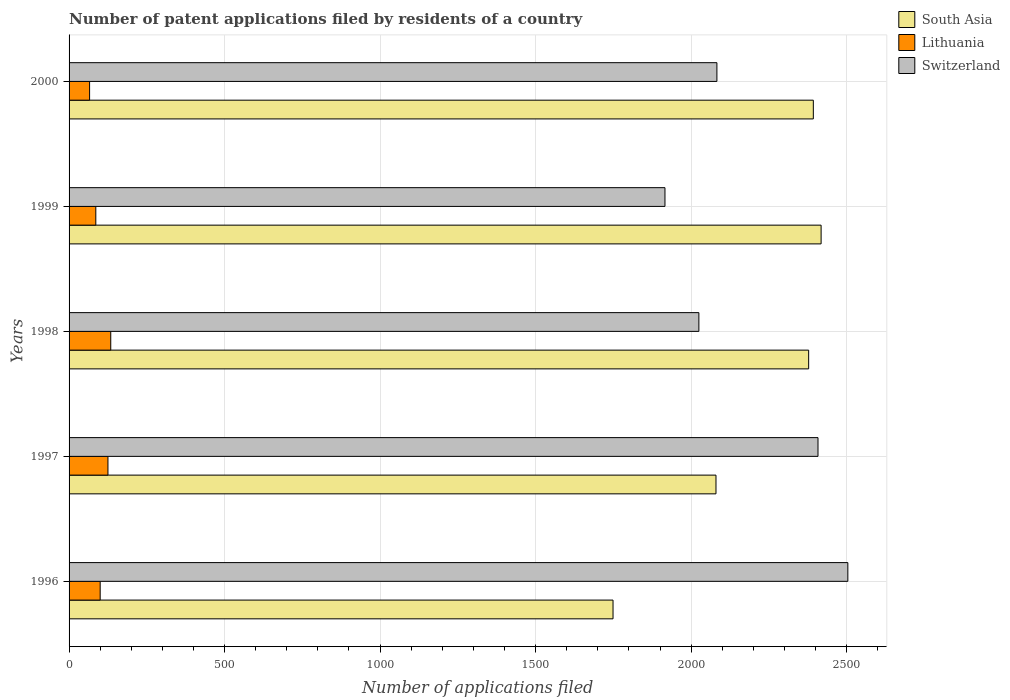How many different coloured bars are there?
Give a very brief answer. 3. How many groups of bars are there?
Your response must be concise. 5. Are the number of bars on each tick of the Y-axis equal?
Offer a terse response. Yes. How many bars are there on the 2nd tick from the top?
Offer a very short reply. 3. In how many cases, is the number of bars for a given year not equal to the number of legend labels?
Give a very brief answer. 0. What is the number of applications filed in Switzerland in 2000?
Offer a terse response. 2083. Across all years, what is the maximum number of applications filed in Lithuania?
Your response must be concise. 134. In which year was the number of applications filed in South Asia minimum?
Your response must be concise. 1996. What is the total number of applications filed in Switzerland in the graph?
Your response must be concise. 1.09e+04. What is the difference between the number of applications filed in South Asia in 1996 and that in 1999?
Give a very brief answer. -669. What is the difference between the number of applications filed in Switzerland in 2000 and the number of applications filed in Lithuania in 1997?
Keep it short and to the point. 1958. What is the average number of applications filed in South Asia per year?
Make the answer very short. 2203.6. In the year 1997, what is the difference between the number of applications filed in Lithuania and number of applications filed in South Asia?
Offer a very short reply. -1955. What is the ratio of the number of applications filed in South Asia in 1996 to that in 1997?
Give a very brief answer. 0.84. Is the difference between the number of applications filed in Lithuania in 1997 and 1999 greater than the difference between the number of applications filed in South Asia in 1997 and 1999?
Give a very brief answer. Yes. What is the difference between the highest and the second highest number of applications filed in South Asia?
Your response must be concise. 25. What is the difference between the highest and the lowest number of applications filed in Switzerland?
Provide a succinct answer. 588. In how many years, is the number of applications filed in Switzerland greater than the average number of applications filed in Switzerland taken over all years?
Ensure brevity in your answer.  2. Is the sum of the number of applications filed in Switzerland in 1998 and 1999 greater than the maximum number of applications filed in Lithuania across all years?
Ensure brevity in your answer.  Yes. What does the 2nd bar from the bottom in 2000 represents?
Offer a very short reply. Lithuania. Is it the case that in every year, the sum of the number of applications filed in Lithuania and number of applications filed in Switzerland is greater than the number of applications filed in South Asia?
Provide a short and direct response. No. How many years are there in the graph?
Offer a terse response. 5. Are the values on the major ticks of X-axis written in scientific E-notation?
Your response must be concise. No. What is the title of the graph?
Make the answer very short. Number of patent applications filed by residents of a country. What is the label or title of the X-axis?
Provide a succinct answer. Number of applications filed. What is the label or title of the Y-axis?
Make the answer very short. Years. What is the Number of applications filed in South Asia in 1996?
Provide a short and direct response. 1749. What is the Number of applications filed in Lithuania in 1996?
Your answer should be very brief. 100. What is the Number of applications filed in Switzerland in 1996?
Offer a very short reply. 2504. What is the Number of applications filed of South Asia in 1997?
Provide a succinct answer. 2080. What is the Number of applications filed in Lithuania in 1997?
Give a very brief answer. 125. What is the Number of applications filed in Switzerland in 1997?
Your answer should be compact. 2408. What is the Number of applications filed of South Asia in 1998?
Offer a terse response. 2378. What is the Number of applications filed in Lithuania in 1998?
Your answer should be very brief. 134. What is the Number of applications filed of Switzerland in 1998?
Make the answer very short. 2025. What is the Number of applications filed in South Asia in 1999?
Provide a succinct answer. 2418. What is the Number of applications filed in Lithuania in 1999?
Keep it short and to the point. 86. What is the Number of applications filed of Switzerland in 1999?
Ensure brevity in your answer.  1916. What is the Number of applications filed of South Asia in 2000?
Your answer should be very brief. 2393. What is the Number of applications filed of Lithuania in 2000?
Keep it short and to the point. 66. What is the Number of applications filed of Switzerland in 2000?
Make the answer very short. 2083. Across all years, what is the maximum Number of applications filed in South Asia?
Your response must be concise. 2418. Across all years, what is the maximum Number of applications filed in Lithuania?
Your response must be concise. 134. Across all years, what is the maximum Number of applications filed of Switzerland?
Give a very brief answer. 2504. Across all years, what is the minimum Number of applications filed of South Asia?
Keep it short and to the point. 1749. Across all years, what is the minimum Number of applications filed of Switzerland?
Offer a very short reply. 1916. What is the total Number of applications filed of South Asia in the graph?
Your answer should be very brief. 1.10e+04. What is the total Number of applications filed of Lithuania in the graph?
Your answer should be compact. 511. What is the total Number of applications filed in Switzerland in the graph?
Keep it short and to the point. 1.09e+04. What is the difference between the Number of applications filed of South Asia in 1996 and that in 1997?
Give a very brief answer. -331. What is the difference between the Number of applications filed in Lithuania in 1996 and that in 1997?
Give a very brief answer. -25. What is the difference between the Number of applications filed of Switzerland in 1996 and that in 1997?
Your answer should be compact. 96. What is the difference between the Number of applications filed of South Asia in 1996 and that in 1998?
Provide a short and direct response. -629. What is the difference between the Number of applications filed in Lithuania in 1996 and that in 1998?
Provide a succinct answer. -34. What is the difference between the Number of applications filed of Switzerland in 1996 and that in 1998?
Your response must be concise. 479. What is the difference between the Number of applications filed of South Asia in 1996 and that in 1999?
Your answer should be compact. -669. What is the difference between the Number of applications filed in Switzerland in 1996 and that in 1999?
Give a very brief answer. 588. What is the difference between the Number of applications filed in South Asia in 1996 and that in 2000?
Offer a terse response. -644. What is the difference between the Number of applications filed of Switzerland in 1996 and that in 2000?
Your response must be concise. 421. What is the difference between the Number of applications filed in South Asia in 1997 and that in 1998?
Your response must be concise. -298. What is the difference between the Number of applications filed of Switzerland in 1997 and that in 1998?
Provide a succinct answer. 383. What is the difference between the Number of applications filed of South Asia in 1997 and that in 1999?
Provide a short and direct response. -338. What is the difference between the Number of applications filed in Lithuania in 1997 and that in 1999?
Offer a terse response. 39. What is the difference between the Number of applications filed in Switzerland in 1997 and that in 1999?
Offer a very short reply. 492. What is the difference between the Number of applications filed of South Asia in 1997 and that in 2000?
Your answer should be compact. -313. What is the difference between the Number of applications filed of Lithuania in 1997 and that in 2000?
Keep it short and to the point. 59. What is the difference between the Number of applications filed in Switzerland in 1997 and that in 2000?
Make the answer very short. 325. What is the difference between the Number of applications filed of Switzerland in 1998 and that in 1999?
Provide a succinct answer. 109. What is the difference between the Number of applications filed in Switzerland in 1998 and that in 2000?
Keep it short and to the point. -58. What is the difference between the Number of applications filed of Switzerland in 1999 and that in 2000?
Give a very brief answer. -167. What is the difference between the Number of applications filed in South Asia in 1996 and the Number of applications filed in Lithuania in 1997?
Provide a short and direct response. 1624. What is the difference between the Number of applications filed of South Asia in 1996 and the Number of applications filed of Switzerland in 1997?
Keep it short and to the point. -659. What is the difference between the Number of applications filed of Lithuania in 1996 and the Number of applications filed of Switzerland in 1997?
Offer a very short reply. -2308. What is the difference between the Number of applications filed of South Asia in 1996 and the Number of applications filed of Lithuania in 1998?
Keep it short and to the point. 1615. What is the difference between the Number of applications filed in South Asia in 1996 and the Number of applications filed in Switzerland in 1998?
Make the answer very short. -276. What is the difference between the Number of applications filed of Lithuania in 1996 and the Number of applications filed of Switzerland in 1998?
Keep it short and to the point. -1925. What is the difference between the Number of applications filed in South Asia in 1996 and the Number of applications filed in Lithuania in 1999?
Offer a terse response. 1663. What is the difference between the Number of applications filed in South Asia in 1996 and the Number of applications filed in Switzerland in 1999?
Offer a very short reply. -167. What is the difference between the Number of applications filed of Lithuania in 1996 and the Number of applications filed of Switzerland in 1999?
Your answer should be compact. -1816. What is the difference between the Number of applications filed of South Asia in 1996 and the Number of applications filed of Lithuania in 2000?
Your response must be concise. 1683. What is the difference between the Number of applications filed of South Asia in 1996 and the Number of applications filed of Switzerland in 2000?
Your answer should be very brief. -334. What is the difference between the Number of applications filed of Lithuania in 1996 and the Number of applications filed of Switzerland in 2000?
Provide a short and direct response. -1983. What is the difference between the Number of applications filed of South Asia in 1997 and the Number of applications filed of Lithuania in 1998?
Your answer should be very brief. 1946. What is the difference between the Number of applications filed of South Asia in 1997 and the Number of applications filed of Switzerland in 1998?
Offer a very short reply. 55. What is the difference between the Number of applications filed of Lithuania in 1997 and the Number of applications filed of Switzerland in 1998?
Ensure brevity in your answer.  -1900. What is the difference between the Number of applications filed in South Asia in 1997 and the Number of applications filed in Lithuania in 1999?
Offer a terse response. 1994. What is the difference between the Number of applications filed of South Asia in 1997 and the Number of applications filed of Switzerland in 1999?
Keep it short and to the point. 164. What is the difference between the Number of applications filed in Lithuania in 1997 and the Number of applications filed in Switzerland in 1999?
Ensure brevity in your answer.  -1791. What is the difference between the Number of applications filed of South Asia in 1997 and the Number of applications filed of Lithuania in 2000?
Ensure brevity in your answer.  2014. What is the difference between the Number of applications filed in South Asia in 1997 and the Number of applications filed in Switzerland in 2000?
Give a very brief answer. -3. What is the difference between the Number of applications filed in Lithuania in 1997 and the Number of applications filed in Switzerland in 2000?
Give a very brief answer. -1958. What is the difference between the Number of applications filed in South Asia in 1998 and the Number of applications filed in Lithuania in 1999?
Offer a very short reply. 2292. What is the difference between the Number of applications filed of South Asia in 1998 and the Number of applications filed of Switzerland in 1999?
Offer a very short reply. 462. What is the difference between the Number of applications filed of Lithuania in 1998 and the Number of applications filed of Switzerland in 1999?
Ensure brevity in your answer.  -1782. What is the difference between the Number of applications filed of South Asia in 1998 and the Number of applications filed of Lithuania in 2000?
Offer a terse response. 2312. What is the difference between the Number of applications filed of South Asia in 1998 and the Number of applications filed of Switzerland in 2000?
Ensure brevity in your answer.  295. What is the difference between the Number of applications filed in Lithuania in 1998 and the Number of applications filed in Switzerland in 2000?
Provide a succinct answer. -1949. What is the difference between the Number of applications filed of South Asia in 1999 and the Number of applications filed of Lithuania in 2000?
Your answer should be compact. 2352. What is the difference between the Number of applications filed in South Asia in 1999 and the Number of applications filed in Switzerland in 2000?
Offer a very short reply. 335. What is the difference between the Number of applications filed in Lithuania in 1999 and the Number of applications filed in Switzerland in 2000?
Offer a terse response. -1997. What is the average Number of applications filed in South Asia per year?
Your response must be concise. 2203.6. What is the average Number of applications filed of Lithuania per year?
Keep it short and to the point. 102.2. What is the average Number of applications filed in Switzerland per year?
Your answer should be very brief. 2187.2. In the year 1996, what is the difference between the Number of applications filed of South Asia and Number of applications filed of Lithuania?
Make the answer very short. 1649. In the year 1996, what is the difference between the Number of applications filed in South Asia and Number of applications filed in Switzerland?
Ensure brevity in your answer.  -755. In the year 1996, what is the difference between the Number of applications filed in Lithuania and Number of applications filed in Switzerland?
Ensure brevity in your answer.  -2404. In the year 1997, what is the difference between the Number of applications filed of South Asia and Number of applications filed of Lithuania?
Your response must be concise. 1955. In the year 1997, what is the difference between the Number of applications filed in South Asia and Number of applications filed in Switzerland?
Provide a short and direct response. -328. In the year 1997, what is the difference between the Number of applications filed in Lithuania and Number of applications filed in Switzerland?
Provide a short and direct response. -2283. In the year 1998, what is the difference between the Number of applications filed in South Asia and Number of applications filed in Lithuania?
Your answer should be compact. 2244. In the year 1998, what is the difference between the Number of applications filed of South Asia and Number of applications filed of Switzerland?
Your response must be concise. 353. In the year 1998, what is the difference between the Number of applications filed in Lithuania and Number of applications filed in Switzerland?
Give a very brief answer. -1891. In the year 1999, what is the difference between the Number of applications filed in South Asia and Number of applications filed in Lithuania?
Give a very brief answer. 2332. In the year 1999, what is the difference between the Number of applications filed in South Asia and Number of applications filed in Switzerland?
Provide a short and direct response. 502. In the year 1999, what is the difference between the Number of applications filed in Lithuania and Number of applications filed in Switzerland?
Offer a very short reply. -1830. In the year 2000, what is the difference between the Number of applications filed of South Asia and Number of applications filed of Lithuania?
Provide a short and direct response. 2327. In the year 2000, what is the difference between the Number of applications filed in South Asia and Number of applications filed in Switzerland?
Provide a succinct answer. 310. In the year 2000, what is the difference between the Number of applications filed of Lithuania and Number of applications filed of Switzerland?
Provide a short and direct response. -2017. What is the ratio of the Number of applications filed in South Asia in 1996 to that in 1997?
Keep it short and to the point. 0.84. What is the ratio of the Number of applications filed of Lithuania in 1996 to that in 1997?
Your answer should be very brief. 0.8. What is the ratio of the Number of applications filed of Switzerland in 1996 to that in 1997?
Ensure brevity in your answer.  1.04. What is the ratio of the Number of applications filed in South Asia in 1996 to that in 1998?
Your answer should be very brief. 0.74. What is the ratio of the Number of applications filed in Lithuania in 1996 to that in 1998?
Offer a very short reply. 0.75. What is the ratio of the Number of applications filed in Switzerland in 1996 to that in 1998?
Provide a succinct answer. 1.24. What is the ratio of the Number of applications filed in South Asia in 1996 to that in 1999?
Your answer should be compact. 0.72. What is the ratio of the Number of applications filed of Lithuania in 1996 to that in 1999?
Provide a succinct answer. 1.16. What is the ratio of the Number of applications filed of Switzerland in 1996 to that in 1999?
Ensure brevity in your answer.  1.31. What is the ratio of the Number of applications filed of South Asia in 1996 to that in 2000?
Provide a short and direct response. 0.73. What is the ratio of the Number of applications filed of Lithuania in 1996 to that in 2000?
Ensure brevity in your answer.  1.52. What is the ratio of the Number of applications filed in Switzerland in 1996 to that in 2000?
Offer a terse response. 1.2. What is the ratio of the Number of applications filed of South Asia in 1997 to that in 1998?
Make the answer very short. 0.87. What is the ratio of the Number of applications filed of Lithuania in 1997 to that in 1998?
Your response must be concise. 0.93. What is the ratio of the Number of applications filed of Switzerland in 1997 to that in 1998?
Provide a succinct answer. 1.19. What is the ratio of the Number of applications filed in South Asia in 1997 to that in 1999?
Make the answer very short. 0.86. What is the ratio of the Number of applications filed in Lithuania in 1997 to that in 1999?
Offer a very short reply. 1.45. What is the ratio of the Number of applications filed in Switzerland in 1997 to that in 1999?
Make the answer very short. 1.26. What is the ratio of the Number of applications filed of South Asia in 1997 to that in 2000?
Your answer should be compact. 0.87. What is the ratio of the Number of applications filed in Lithuania in 1997 to that in 2000?
Offer a terse response. 1.89. What is the ratio of the Number of applications filed of Switzerland in 1997 to that in 2000?
Offer a very short reply. 1.16. What is the ratio of the Number of applications filed in South Asia in 1998 to that in 1999?
Ensure brevity in your answer.  0.98. What is the ratio of the Number of applications filed of Lithuania in 1998 to that in 1999?
Provide a succinct answer. 1.56. What is the ratio of the Number of applications filed of Switzerland in 1998 to that in 1999?
Offer a terse response. 1.06. What is the ratio of the Number of applications filed in South Asia in 1998 to that in 2000?
Offer a very short reply. 0.99. What is the ratio of the Number of applications filed in Lithuania in 1998 to that in 2000?
Offer a very short reply. 2.03. What is the ratio of the Number of applications filed of Switzerland in 1998 to that in 2000?
Give a very brief answer. 0.97. What is the ratio of the Number of applications filed of South Asia in 1999 to that in 2000?
Offer a terse response. 1.01. What is the ratio of the Number of applications filed in Lithuania in 1999 to that in 2000?
Your response must be concise. 1.3. What is the ratio of the Number of applications filed in Switzerland in 1999 to that in 2000?
Provide a succinct answer. 0.92. What is the difference between the highest and the second highest Number of applications filed of South Asia?
Give a very brief answer. 25. What is the difference between the highest and the second highest Number of applications filed of Lithuania?
Offer a terse response. 9. What is the difference between the highest and the second highest Number of applications filed of Switzerland?
Keep it short and to the point. 96. What is the difference between the highest and the lowest Number of applications filed of South Asia?
Provide a short and direct response. 669. What is the difference between the highest and the lowest Number of applications filed of Switzerland?
Keep it short and to the point. 588. 